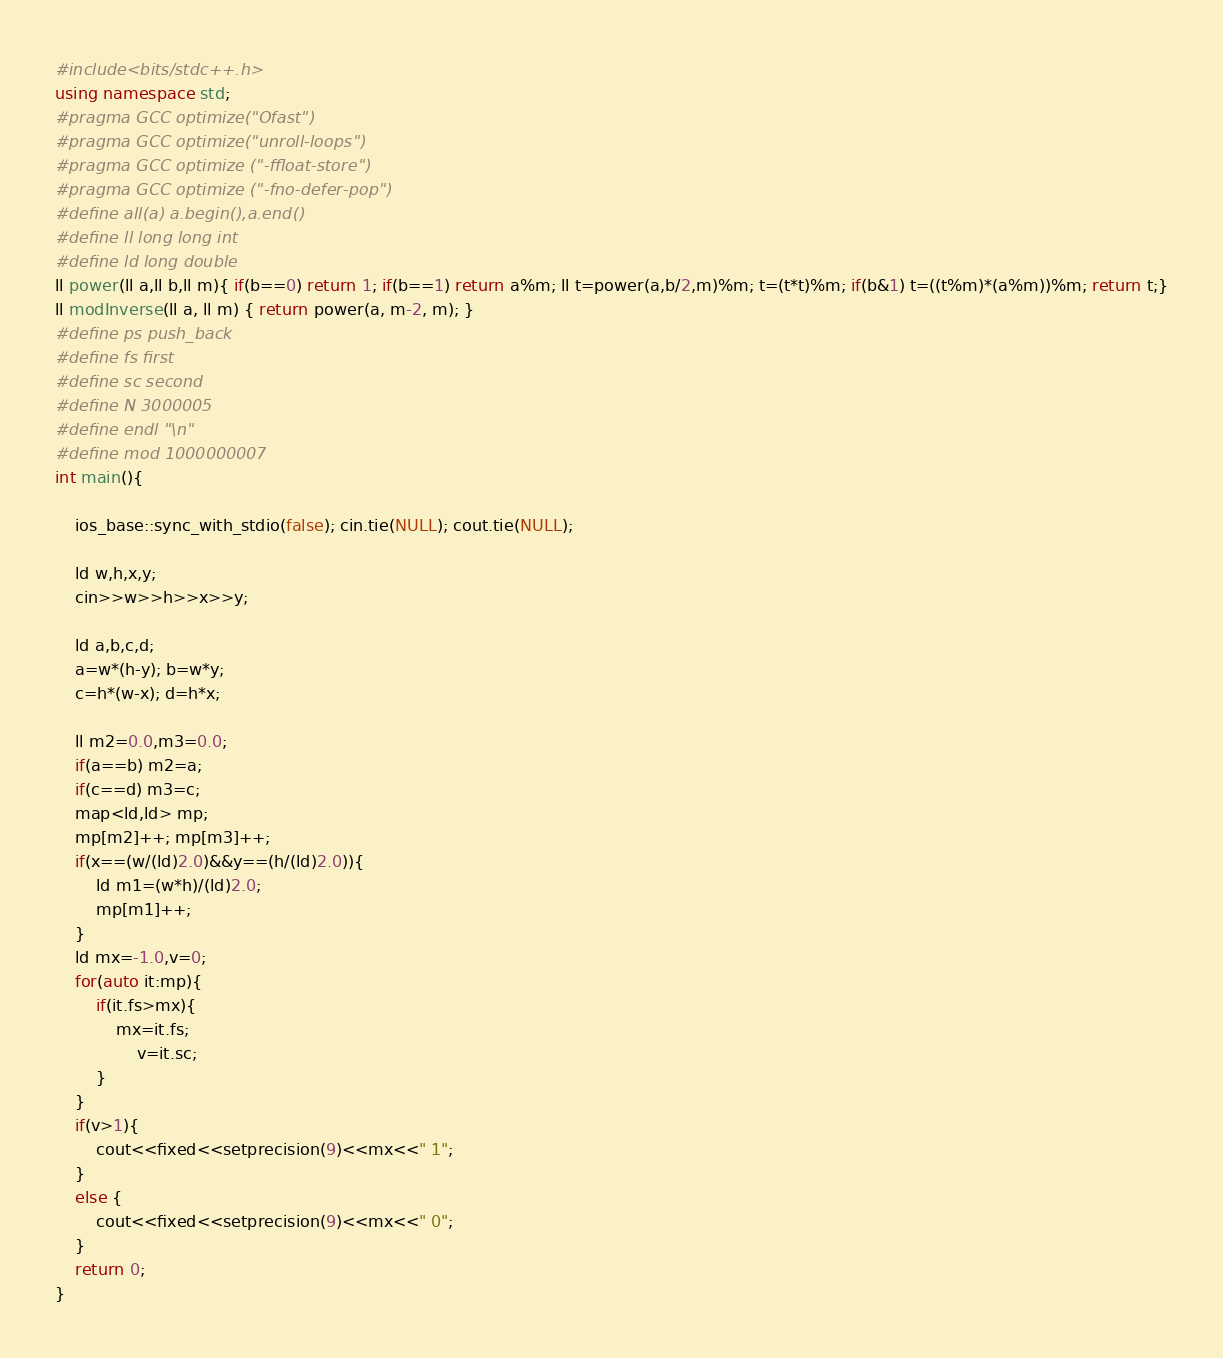<code> <loc_0><loc_0><loc_500><loc_500><_C++_>#include<bits/stdc++.h>
using namespace std;
#pragma GCC optimize("Ofast")
#pragma GCC optimize("unroll-loops")
#pragma GCC optimize ("-ffloat-store")  
#pragma GCC optimize ("-fno-defer-pop")
#define all(a) a.begin(),a.end()
#define ll long long int
#define ld long double
ll power(ll a,ll b,ll m){ if(b==0) return 1; if(b==1) return a%m; ll t=power(a,b/2,m)%m; t=(t*t)%m; if(b&1) t=((t%m)*(a%m))%m; return t;}
ll modInverse(ll a, ll m) { return power(a, m-2, m); }
#define ps push_back
#define fs first
#define sc second
#define N 3000005
#define endl "\n"
#define mod 1000000007
int main(){
	
	ios_base::sync_with_stdio(false); cin.tie(NULL); cout.tie(NULL);
	
	ld w,h,x,y;
	cin>>w>>h>>x>>y;

	ld a,b,c,d;
	a=w*(h-y); b=w*y;
	c=h*(w-x); d=h*x;

	ll m2=0.0,m3=0.0;
	if(a==b) m2=a;
	if(c==d) m3=c;
	map<ld,ld> mp;
	mp[m2]++; mp[m3]++;
	if(x==(w/(ld)2.0)&&y==(h/(ld)2.0)){
		ld m1=(w*h)/(ld)2.0;
		mp[m1]++;
	}
	ld mx=-1.0,v=0;
	for(auto it:mp){
		if(it.fs>mx){
			mx=it.fs;
				v=it.sc;
		}
	}
	if(v>1){
		cout<<fixed<<setprecision(9)<<mx<<" 1";
	}
	else {
		cout<<fixed<<setprecision(9)<<mx<<" 0";
	}
	return 0;
}
</code> 